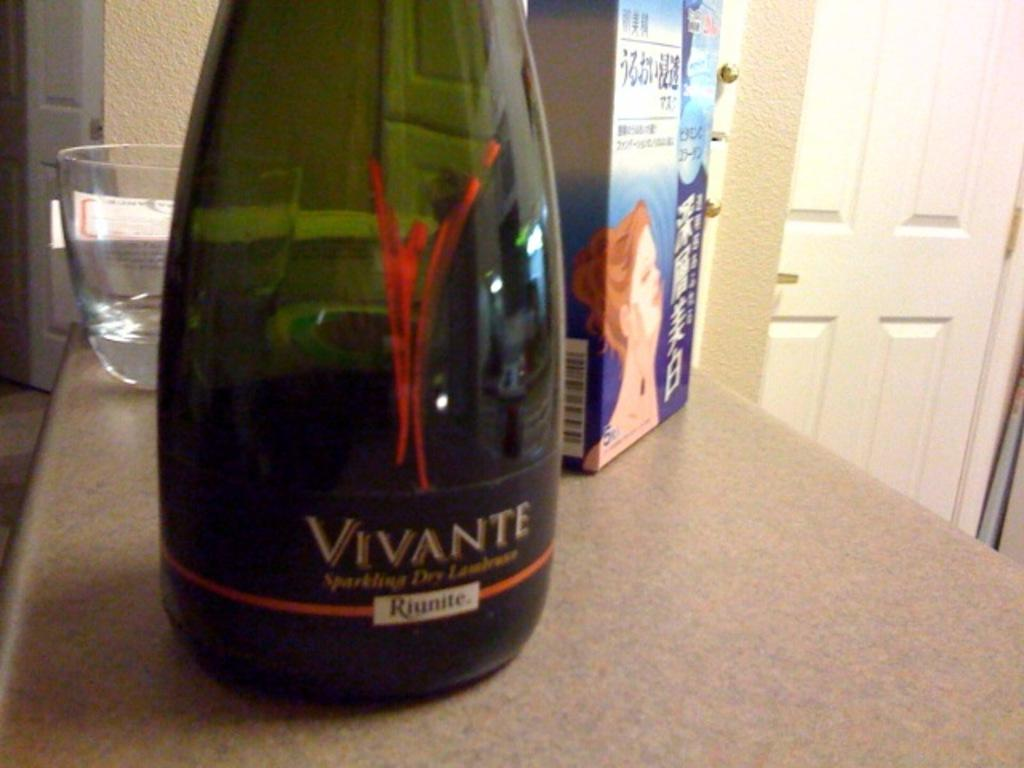<image>
Describe the image concisely. the word Vivante that is on a wine bottle 